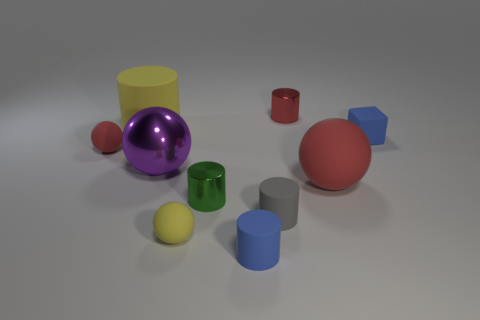Subtract all yellow balls. How many balls are left? 3 Subtract all purple spheres. How many spheres are left? 3 Subtract 2 spheres. How many spheres are left? 2 Subtract all gray cylinders. Subtract all cyan spheres. How many cylinders are left? 4 Subtract all cubes. How many objects are left? 9 Add 1 purple shiny balls. How many purple shiny balls are left? 2 Add 1 blue metallic things. How many blue metallic things exist? 1 Subtract 0 green spheres. How many objects are left? 10 Subtract all tiny green matte cubes. Subtract all red shiny objects. How many objects are left? 9 